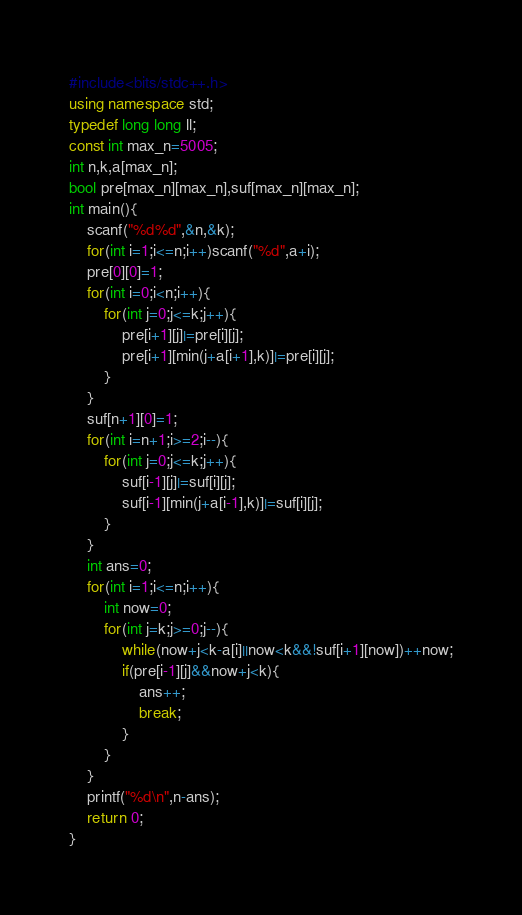Convert code to text. <code><loc_0><loc_0><loc_500><loc_500><_C++_>#include<bits/stdc++.h>
using namespace std;
typedef long long ll;
const int max_n=5005;
int n,k,a[max_n];
bool pre[max_n][max_n],suf[max_n][max_n];
int main(){
    scanf("%d%d",&n,&k);
    for(int i=1;i<=n;i++)scanf("%d",a+i);
    pre[0][0]=1;
    for(int i=0;i<n;i++){
        for(int j=0;j<=k;j++){
            pre[i+1][j]|=pre[i][j];
            pre[i+1][min(j+a[i+1],k)]|=pre[i][j];
        }
    }
    suf[n+1][0]=1;
    for(int i=n+1;i>=2;i--){
        for(int j=0;j<=k;j++){
            suf[i-1][j]|=suf[i][j];
            suf[i-1][min(j+a[i-1],k)]|=suf[i][j];
        }
    }
    int ans=0;
    for(int i=1;i<=n;i++){
        int now=0;
        for(int j=k;j>=0;j--){
            while(now+j<k-a[i]||now<k&&!suf[i+1][now])++now;
            if(pre[i-1][j]&&now+j<k){
                ans++;
                break;
            }
        }
    }
    printf("%d\n",n-ans);
    return 0;
}</code> 